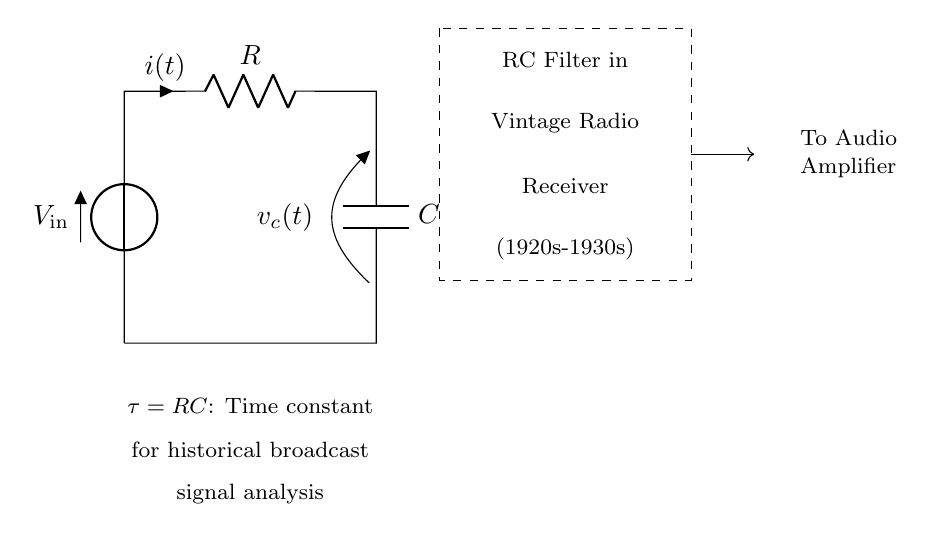What type of filter is depicted in this circuit? The circuit shows an RC filter, which is a combination of a resistor and a capacitor used to filter out certain frequencies. The dashed box specifies it as an RC filter in vintage radios.
Answer: RC filter What does the variable C represent? In the circuit diagram, C indicates the capacitance value of the capacitor. This value determines how much charge the capacitor can store.
Answer: Capacitance What is the current direction indicated in the diagram? The current direction is indicated by the arrow (i) next to the resistor R, showing that current flows from the voltage source through the resistor and then to the capacitor.
Answer: From V_in through R to C What is the significance of the time constant tau? Tau, represented as RC, denotes the time constant of the RC circuit, which helps determine how quickly the capacitor charges and discharges. It's crucial for analyzing historical broadcast signal response times.
Answer: RC How does the output voltage relate to the input in this filter? The output voltage across the capacitor responds to the input voltage, where the capacitor charges and discharges based on the input's frequency. Low frequencies pass through, while high frequencies are attenuated.
Answer: Frequency-dependent What decade is specified for the vintage radio receiver shown? The diagram clearly states that the vintage radio receiver is from the 1920s-1930s, indicating the historical context in which this circuit was used.
Answer: 1920s-1930s What does the label "V_in" represent in the circuit? The label V_in signifies the input voltage, which is supplied to the circuit and is essential in analyzing how the RC circuit processes this incoming signal.
Answer: Input voltage 